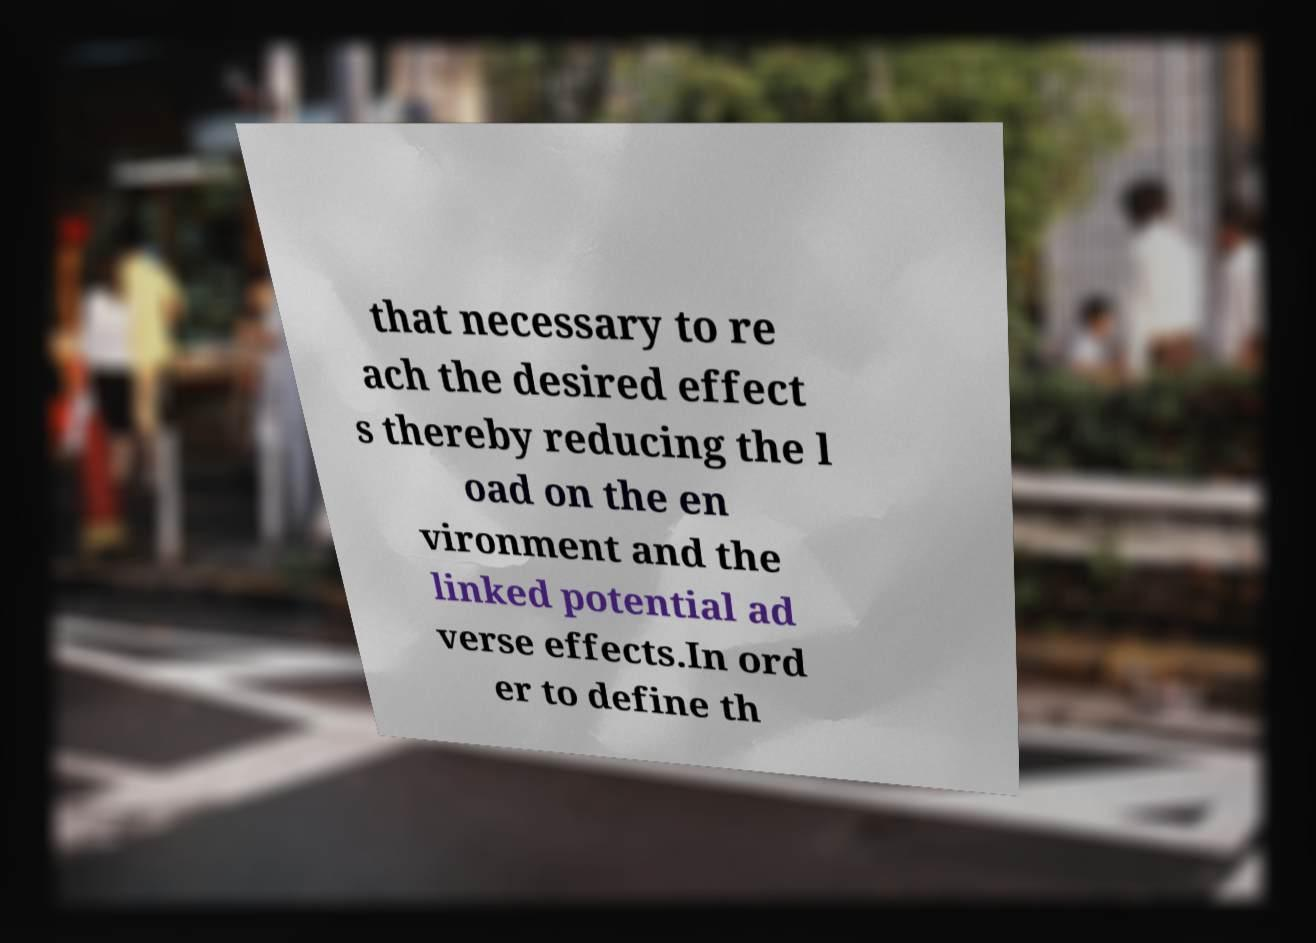Please identify and transcribe the text found in this image. that necessary to re ach the desired effect s thereby reducing the l oad on the en vironment and the linked potential ad verse effects.In ord er to define th 